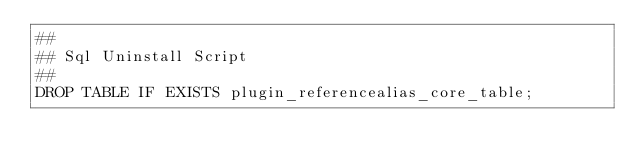<code> <loc_0><loc_0><loc_500><loc_500><_SQL_>##
## Sql Uninstall Script
##
DROP TABLE IF EXISTS plugin_referencealias_core_table;
</code> 